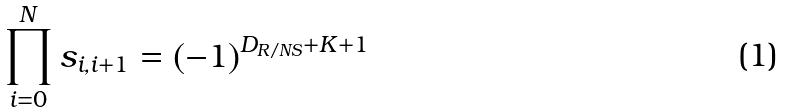<formula> <loc_0><loc_0><loc_500><loc_500>\prod _ { i = 0 } ^ { N } s _ { i , i + 1 } = ( - 1 ) ^ { D _ { R / N S } + K + 1 }</formula> 